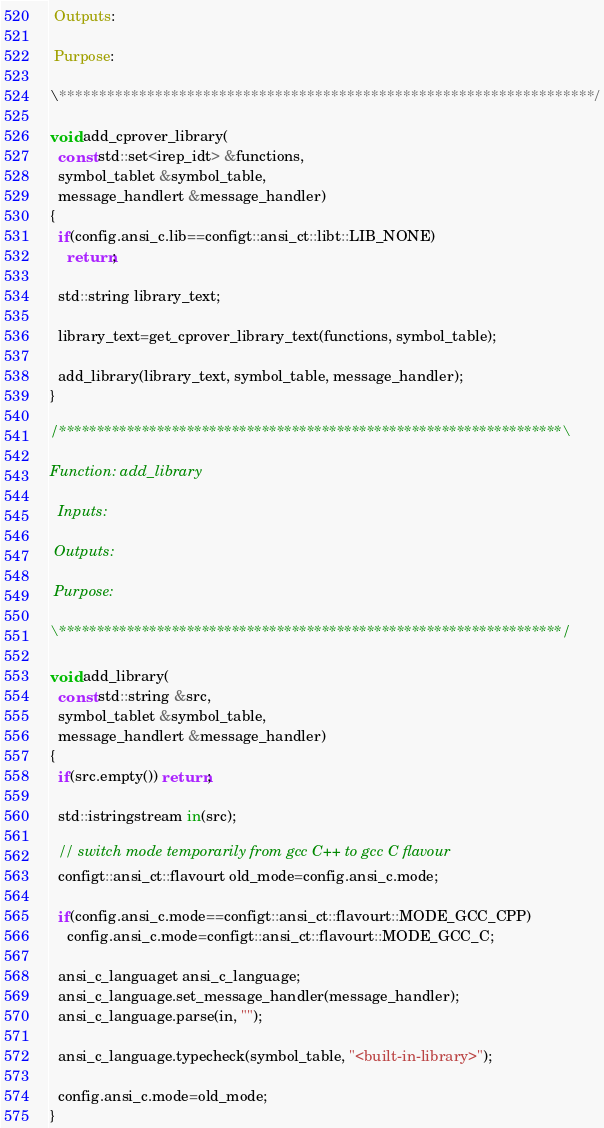Convert code to text. <code><loc_0><loc_0><loc_500><loc_500><_C++_>
 Outputs:

 Purpose:

\*******************************************************************/

void add_cprover_library(
  const std::set<irep_idt> &functions,
  symbol_tablet &symbol_table,
  message_handlert &message_handler)
{
  if(config.ansi_c.lib==configt::ansi_ct::libt::LIB_NONE)
    return;
    
  std::string library_text;

  library_text=get_cprover_library_text(functions, symbol_table);
  
  add_library(library_text, symbol_table, message_handler);
}

/*******************************************************************\

Function: add_library

  Inputs:

 Outputs:

 Purpose:

\*******************************************************************/

void add_library(
  const std::string &src,
  symbol_tablet &symbol_table,
  message_handlert &message_handler)
{
  if(src.empty()) return;

  std::istringstream in(src);

  // switch mode temporarily from gcc C++ to gcc C flavour
  configt::ansi_ct::flavourt old_mode=config.ansi_c.mode;
  
  if(config.ansi_c.mode==configt::ansi_ct::flavourt::MODE_GCC_CPP)
    config.ansi_c.mode=configt::ansi_ct::flavourt::MODE_GCC_C;
  
  ansi_c_languaget ansi_c_language;
  ansi_c_language.set_message_handler(message_handler);
  ansi_c_language.parse(in, "");
  
  ansi_c_language.typecheck(symbol_table, "<built-in-library>");

  config.ansi_c.mode=old_mode;
}
</code> 